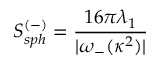Convert formula to latex. <formula><loc_0><loc_0><loc_500><loc_500>S _ { s p h } ^ { ( - ) } = \frac { 1 6 \pi \lambda _ { 1 } } { | \omega _ { - } ( \kappa ^ { 2 } ) | }</formula> 